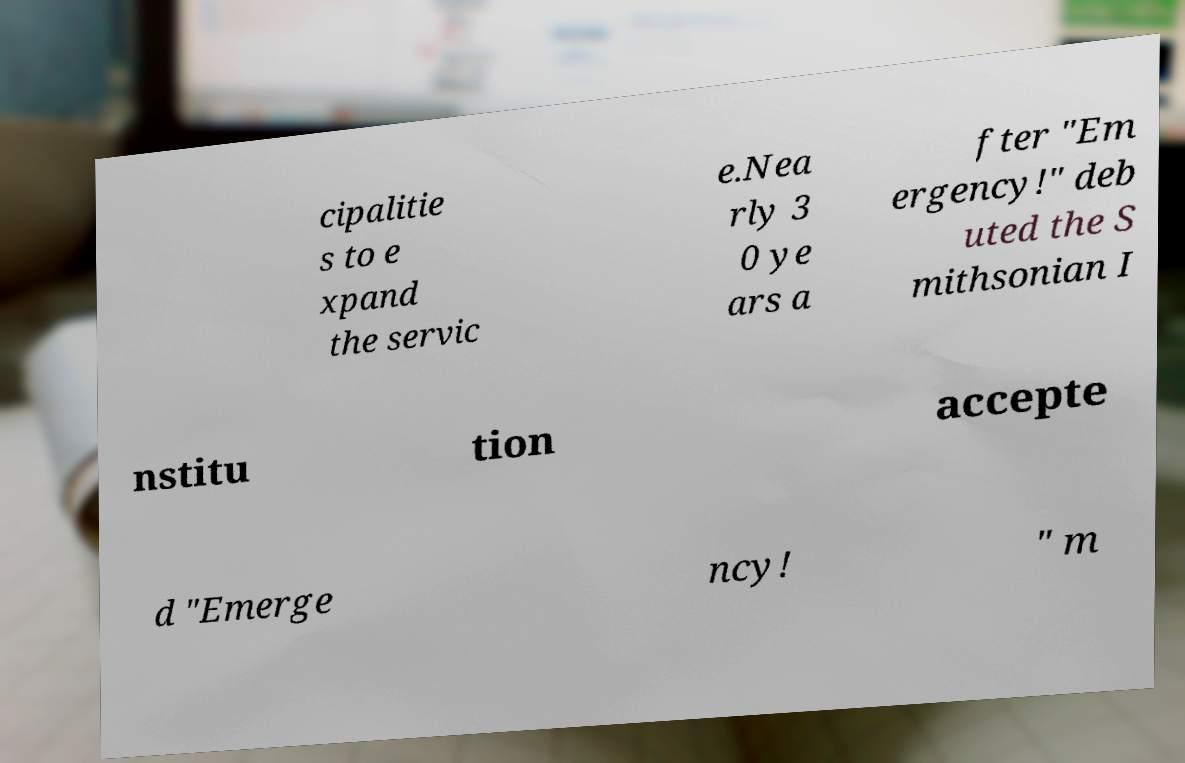Please identify and transcribe the text found in this image. cipalitie s to e xpand the servic e.Nea rly 3 0 ye ars a fter "Em ergency!" deb uted the S mithsonian I nstitu tion accepte d "Emerge ncy! " m 